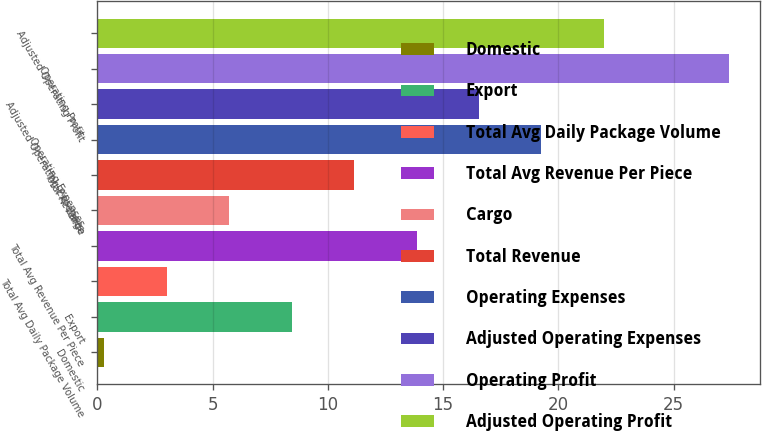Convert chart to OTSL. <chart><loc_0><loc_0><loc_500><loc_500><bar_chart><fcel>Domestic<fcel>Export<fcel>Total Avg Daily Package Volume<fcel>Total Avg Revenue Per Piece<fcel>Cargo<fcel>Total Revenue<fcel>Operating Expenses<fcel>Adjusted Operating Expenses<fcel>Operating Profit<fcel>Adjusted Operating Profit<nl><fcel>0.3<fcel>8.43<fcel>3.01<fcel>13.85<fcel>5.72<fcel>11.14<fcel>19.27<fcel>16.56<fcel>27.4<fcel>21.98<nl></chart> 